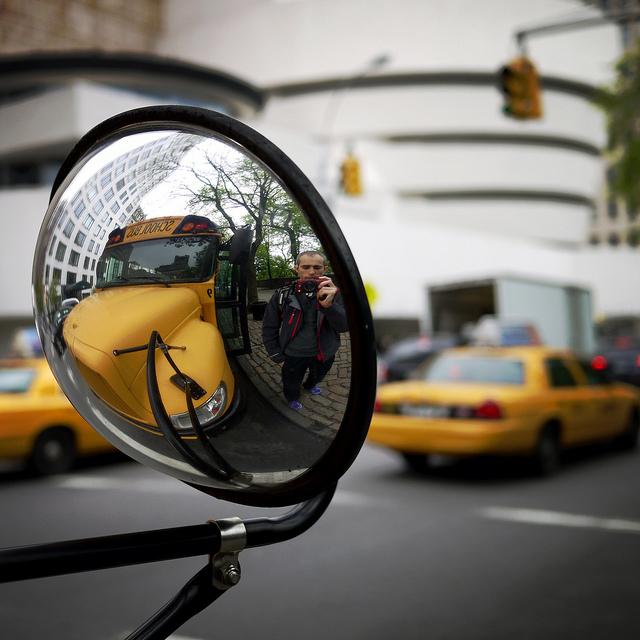What type of vehicle is the mirror attached to?
Concise answer only. Bus. How many things are yellow?
Concise answer only. 3. Is there a sign on the building reflected?
Quick response, please. No. What is in the mirror?
Keep it brief. School bus. Can you see the back end of the yellow car?
Write a very short answer. Yes. How many taxi cabs are in the picture?
Answer briefly. 2. 